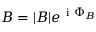<formula> <loc_0><loc_0><loc_500><loc_500>B = | B | e ^ { i \Phi _ { B } }</formula> 